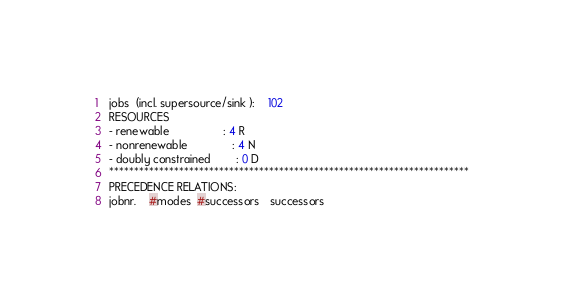Convert code to text. <code><loc_0><loc_0><loc_500><loc_500><_ObjectiveC_>jobs  (incl. supersource/sink ):	102
RESOURCES
- renewable                 : 4 R
- nonrenewable              : 4 N
- doubly constrained        : 0 D
************************************************************************
PRECEDENCE RELATIONS:
jobnr.    #modes  #successors   successors</code> 